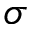<formula> <loc_0><loc_0><loc_500><loc_500>\sigma</formula> 